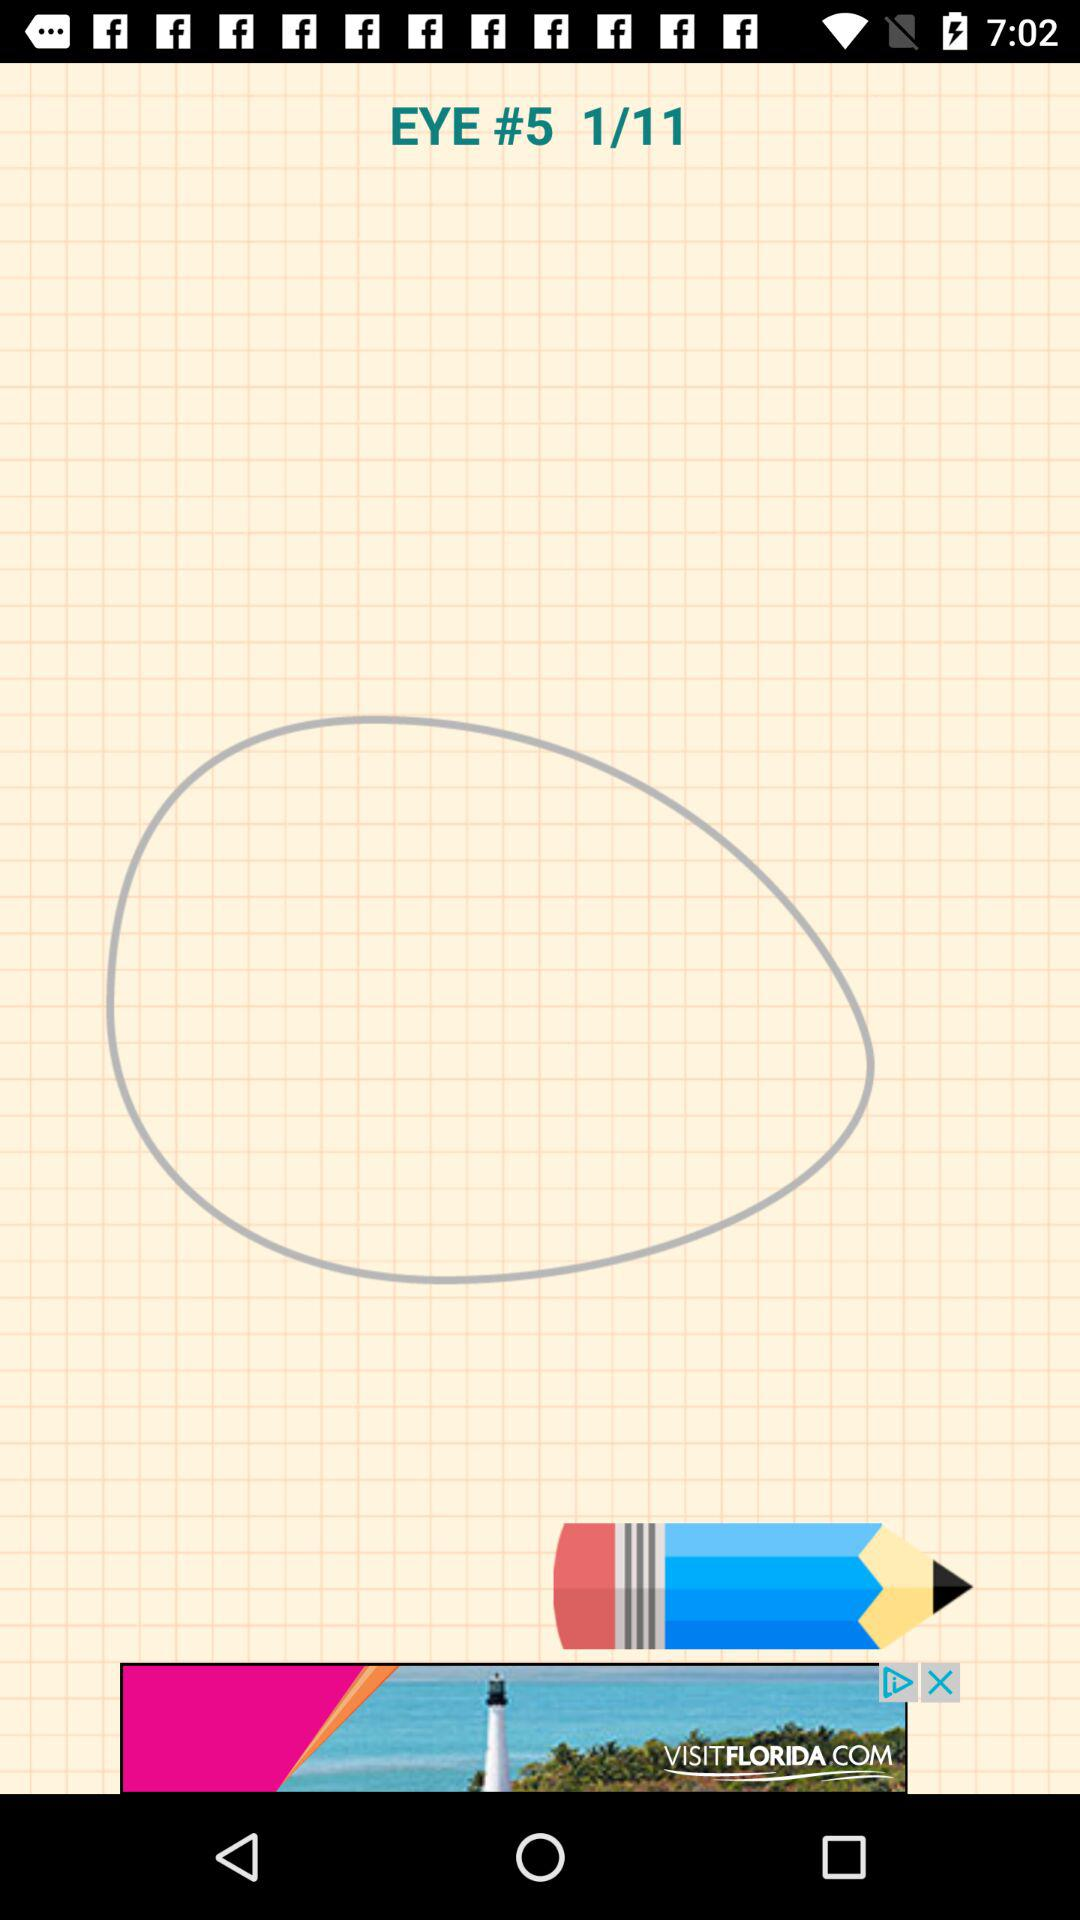How many images are there in total? There are a total of 11 images. 